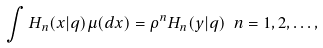<formula> <loc_0><loc_0><loc_500><loc_500>\int H _ { n } ( x | q ) \mu ( d x ) = \rho ^ { n } H _ { n } ( y | q ) \ n = 1 , 2 , \dots ,</formula> 